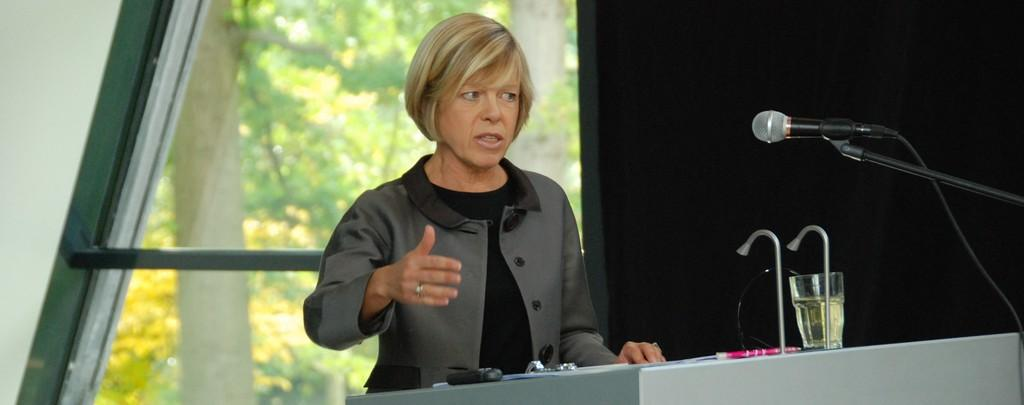Who is the main subject in the image? There is a woman in the image. What is the woman doing in the image? The woman is standing in front of a podium. What objects are on the podium? There is a glass and a microphone on the podium. What is the woman wearing in the image? The woman is wearing a coat. What can be seen in the background of the image? There are trees in the background of the image. What type of cream can be seen being poured by the band in the image? There is no band or cream present in the image. How does the flock of birds interact with the woman in the image? There are no birds or flock present in the image. 